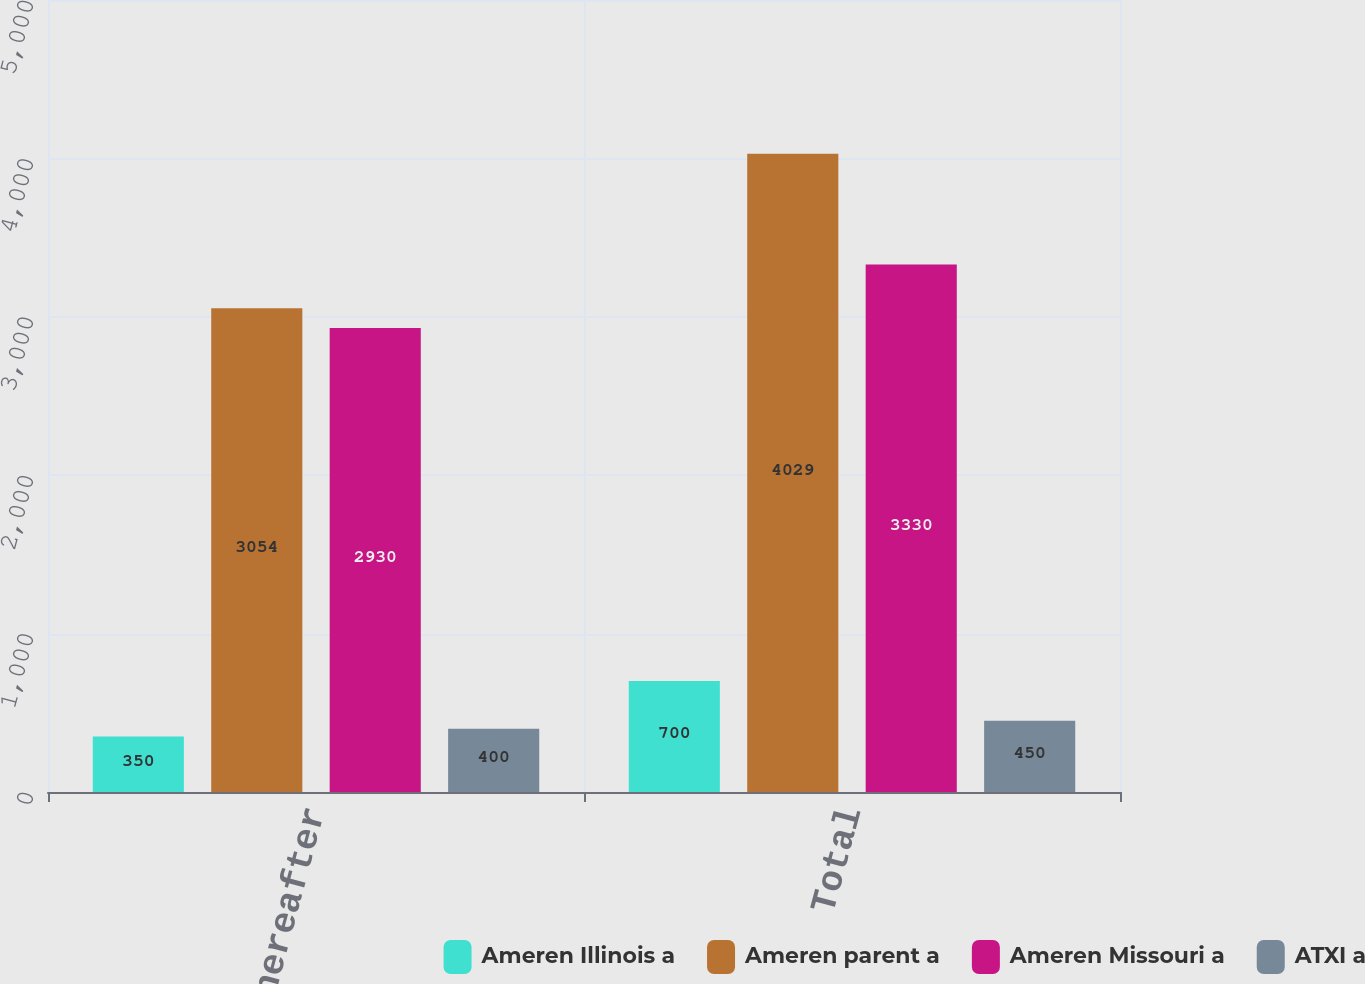Convert chart to OTSL. <chart><loc_0><loc_0><loc_500><loc_500><stacked_bar_chart><ecel><fcel>Thereafter<fcel>Total<nl><fcel>Ameren Illinois a<fcel>350<fcel>700<nl><fcel>Ameren parent a<fcel>3054<fcel>4029<nl><fcel>Ameren Missouri a<fcel>2930<fcel>3330<nl><fcel>ATXI a<fcel>400<fcel>450<nl></chart> 